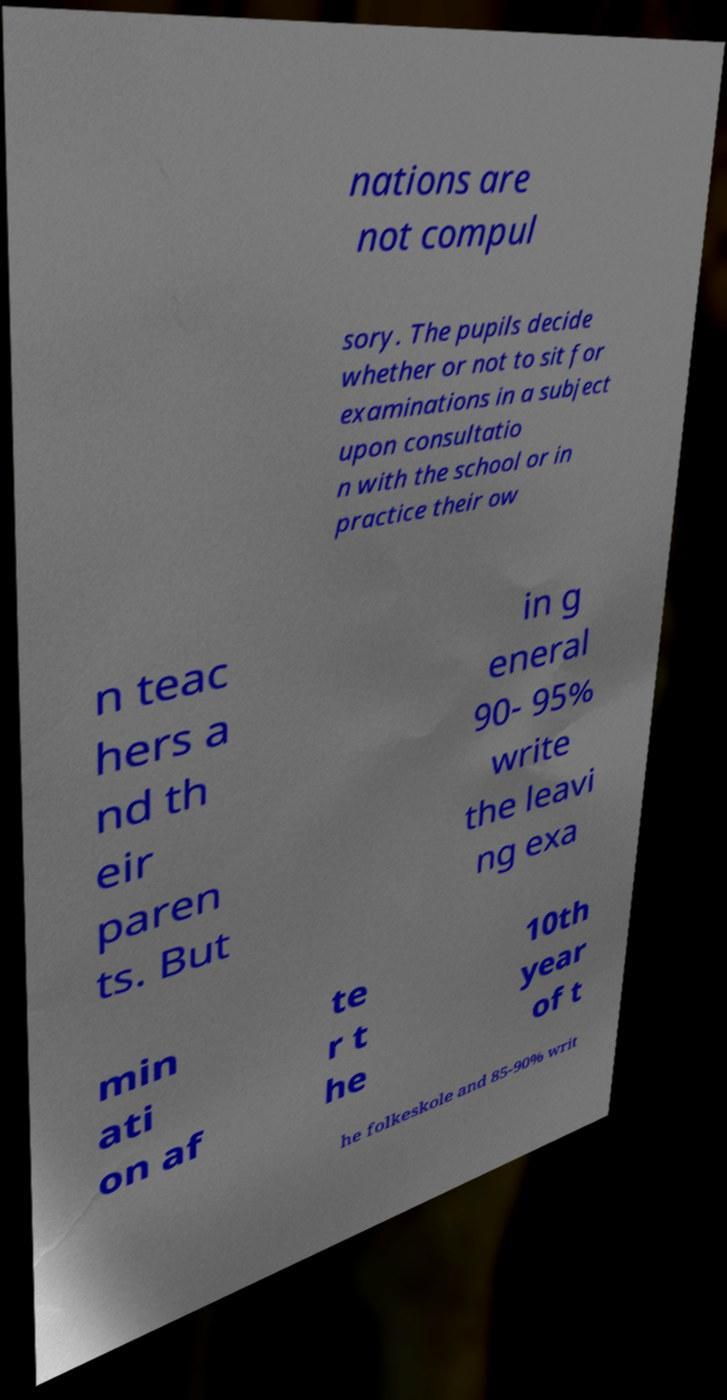Could you assist in decoding the text presented in this image and type it out clearly? nations are not compul sory. The pupils decide whether or not to sit for examinations in a subject upon consultatio n with the school or in practice their ow n teac hers a nd th eir paren ts. But in g eneral 90- 95% write the leavi ng exa min ati on af te r t he 10th year of t he folkeskole and 85-90% writ 